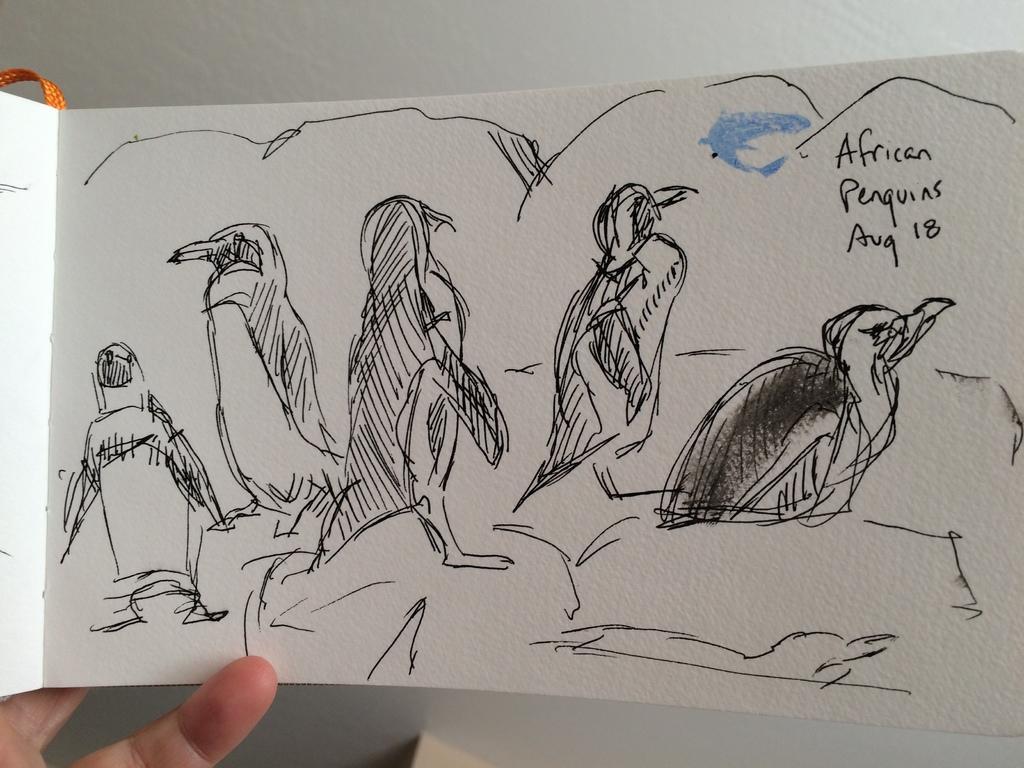Could you give a brief overview of what you see in this image? In this image I can see the sketch of the animals on the white color paper. The person is holding the paper. Background is in white color. 